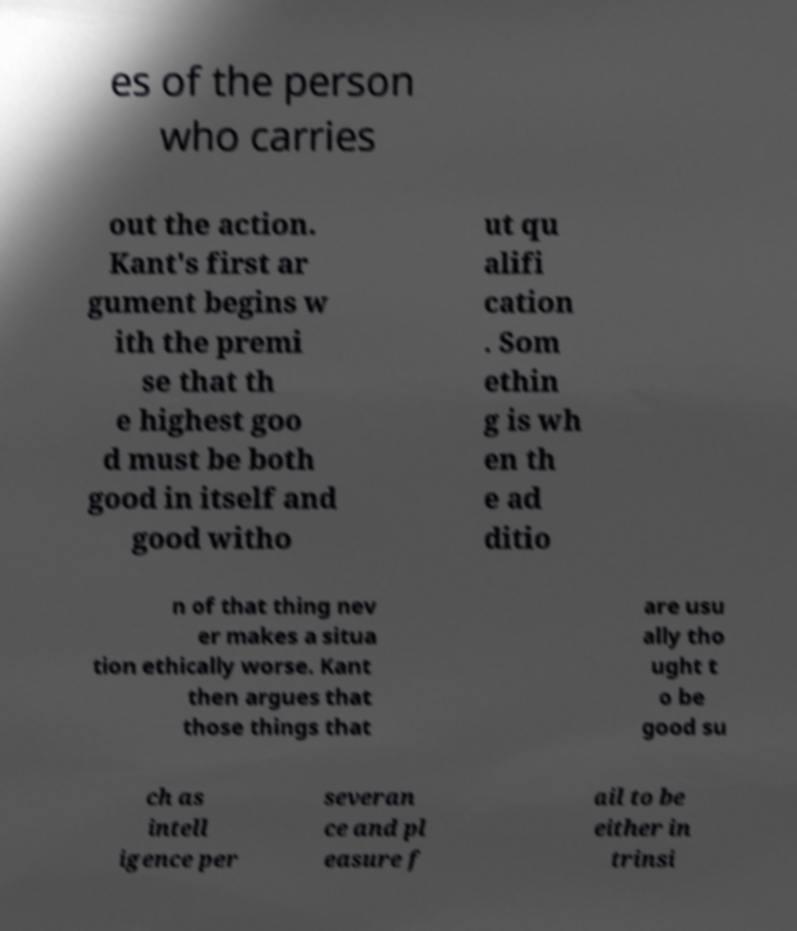What messages or text are displayed in this image? I need them in a readable, typed format. es of the person who carries out the action. Kant's first ar gument begins w ith the premi se that th e highest goo d must be both good in itself and good witho ut qu alifi cation . Som ethin g is wh en th e ad ditio n of that thing nev er makes a situa tion ethically worse. Kant then argues that those things that are usu ally tho ught t o be good su ch as intell igence per severan ce and pl easure f ail to be either in trinsi 